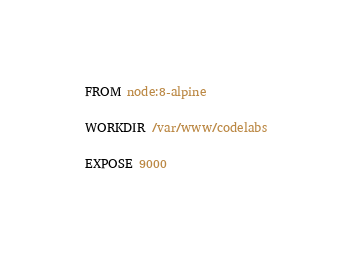<code> <loc_0><loc_0><loc_500><loc_500><_Dockerfile_>FROM node:8-alpine

WORKDIR /var/www/codelabs

EXPOSE 9000
</code> 